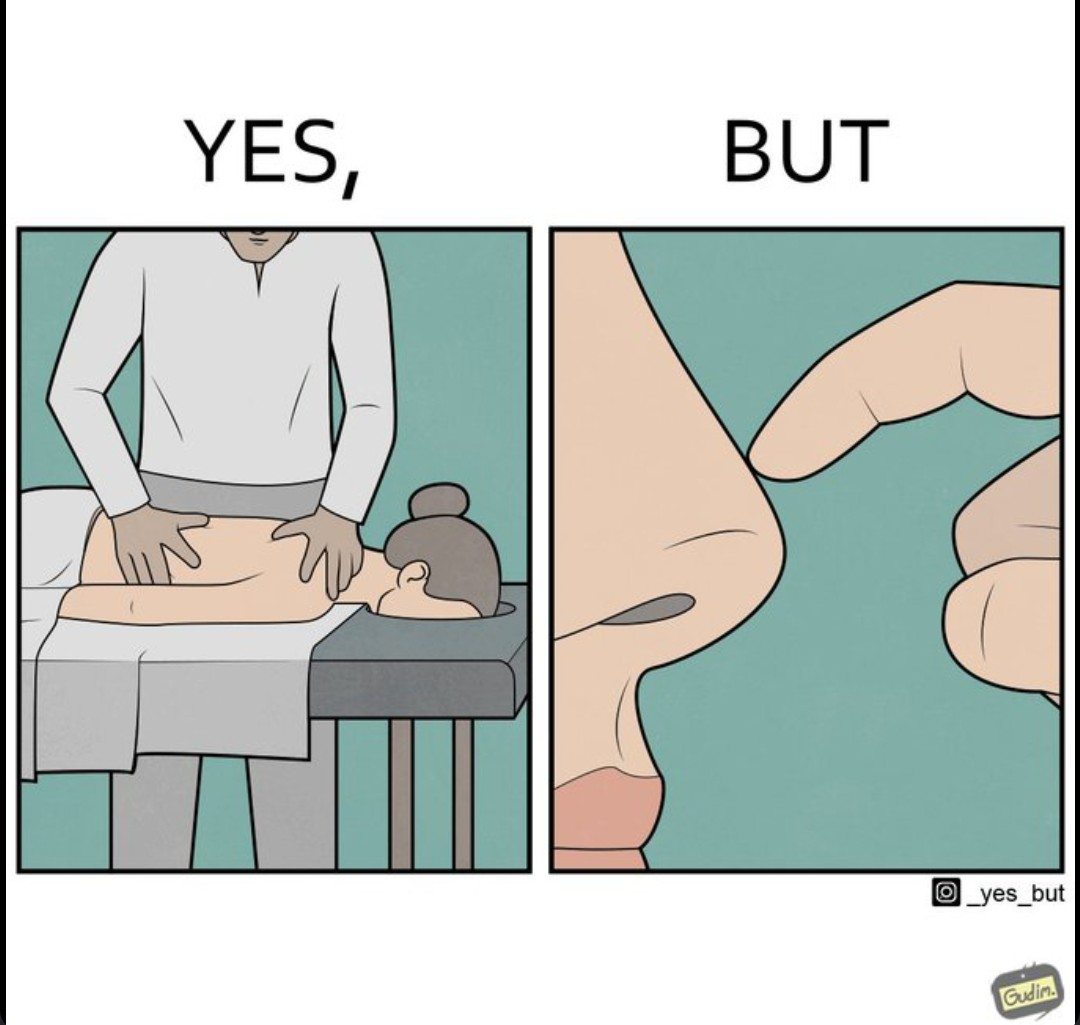Describe what you see in this image. The images are funny since even though a woman goes for a full body massage expecting it to soothe her whole body, the design of a massage table is such that no matter how badly her nose itches, she cannot scratch it to soothe herself 